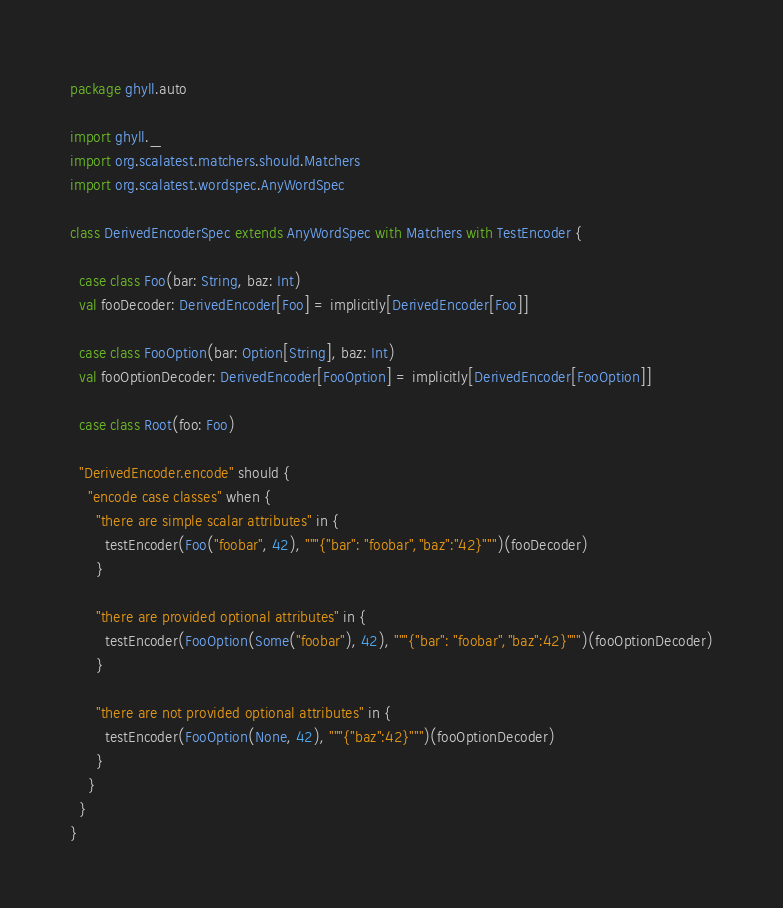Convert code to text. <code><loc_0><loc_0><loc_500><loc_500><_Scala_>package ghyll.auto

import ghyll._
import org.scalatest.matchers.should.Matchers
import org.scalatest.wordspec.AnyWordSpec

class DerivedEncoderSpec extends AnyWordSpec with Matchers with TestEncoder {

  case class Foo(bar: String, baz: Int)
  val fooDecoder: DerivedEncoder[Foo] = implicitly[DerivedEncoder[Foo]]

  case class FooOption(bar: Option[String], baz: Int)
  val fooOptionDecoder: DerivedEncoder[FooOption] = implicitly[DerivedEncoder[FooOption]]

  case class Root(foo: Foo)

  "DerivedEncoder.encode" should {
    "encode case classes" when {
      "there are simple scalar attributes" in {
        testEncoder(Foo("foobar", 42), """{"bar": "foobar","baz":"42}""")(fooDecoder)
      }

      "there are provided optional attributes" in {
        testEncoder(FooOption(Some("foobar"), 42), """{"bar": "foobar","baz":42}""")(fooOptionDecoder)
      }

      "there are not provided optional attributes" in {
        testEncoder(FooOption(None, 42), """{"baz":42}""")(fooOptionDecoder)
      }
    }
  }
}
</code> 